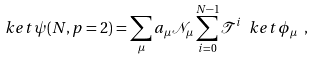Convert formula to latex. <formula><loc_0><loc_0><loc_500><loc_500>\ k e t { \psi ( N , p = 2 ) } = \sum _ { \mu } a _ { \mu } \mathcal { N } _ { \mu } \sum _ { i = 0 } ^ { N - 1 } { \mathcal { T } } ^ { i } \ k e t { \phi _ { \mu } } \ ,</formula> 